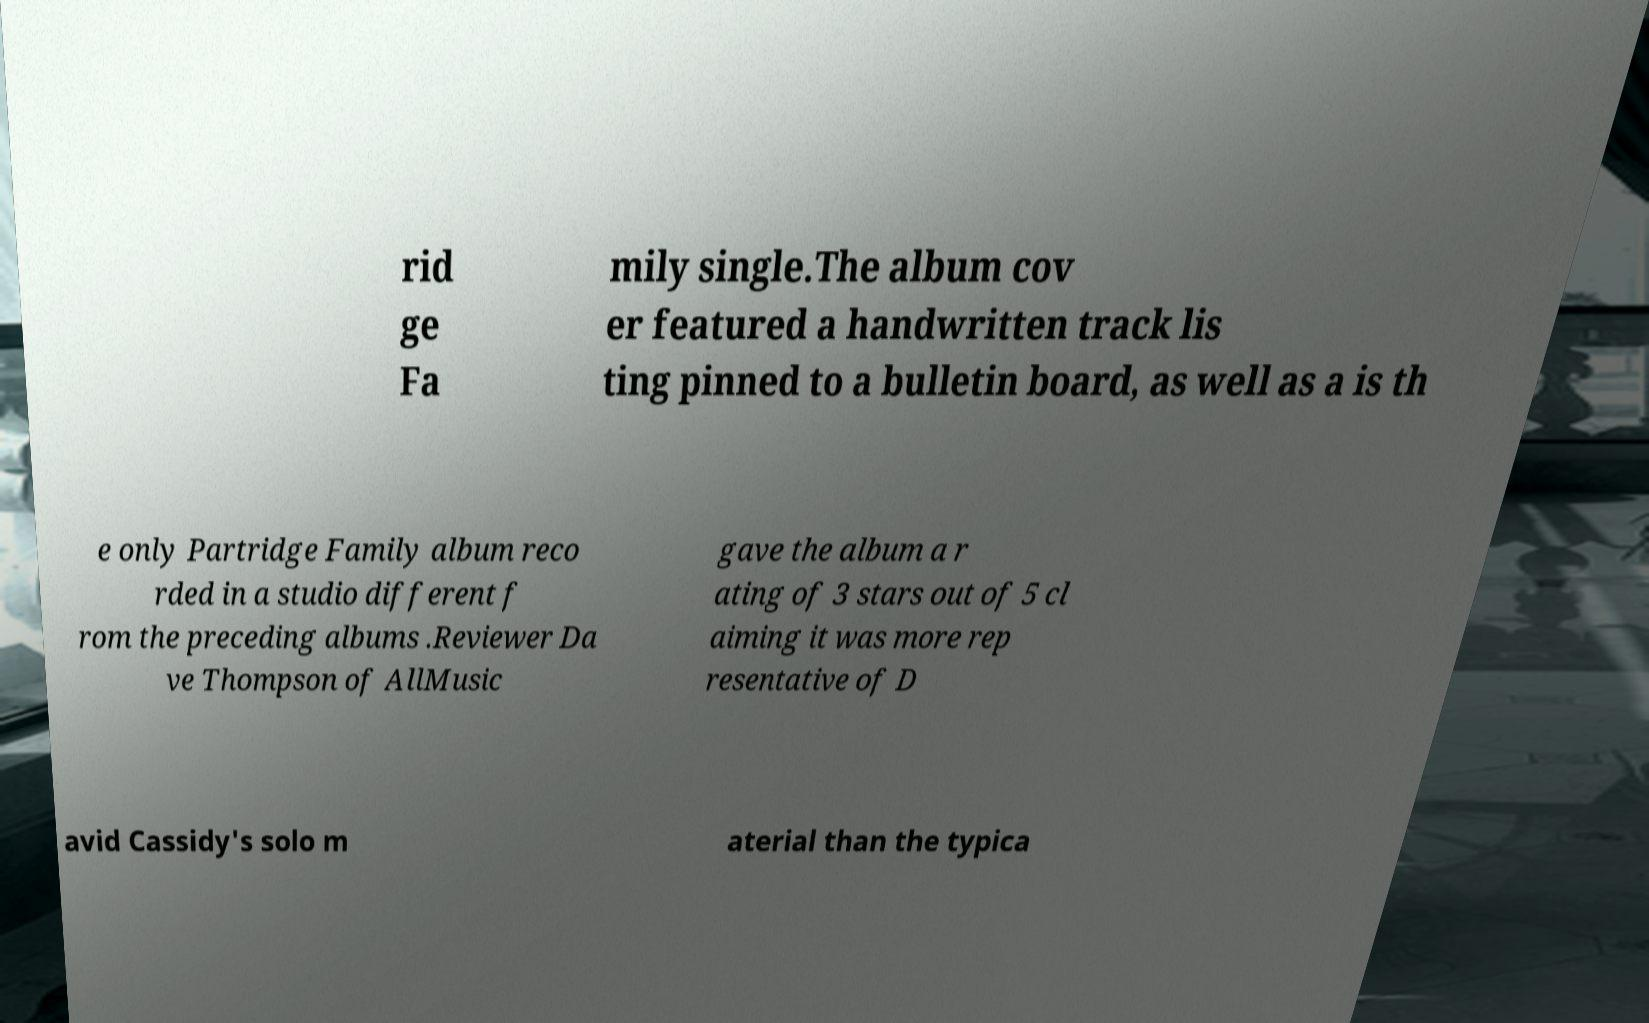Could you extract and type out the text from this image? rid ge Fa mily single.The album cov er featured a handwritten track lis ting pinned to a bulletin board, as well as a is th e only Partridge Family album reco rded in a studio different f rom the preceding albums .Reviewer Da ve Thompson of AllMusic gave the album a r ating of 3 stars out of 5 cl aiming it was more rep resentative of D avid Cassidy's solo m aterial than the typica 